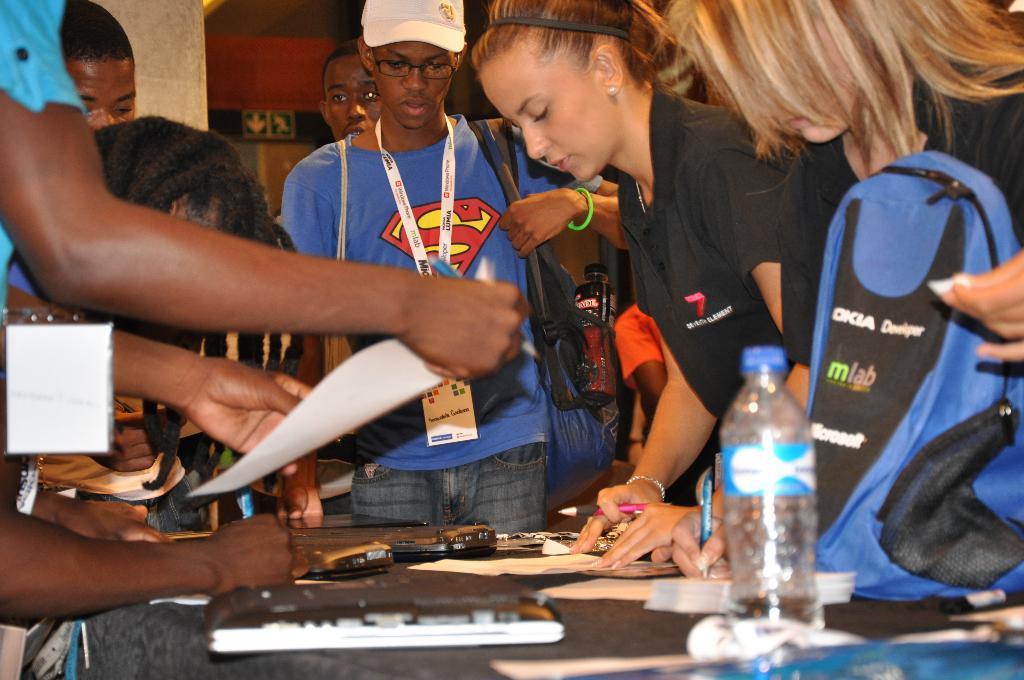Please provide a concise description of this image. There are some people standing in front of the table and some are sitting some people are holding a paper and some people are writing with the help of table there is a bottle on the table and 1 blue color bag 